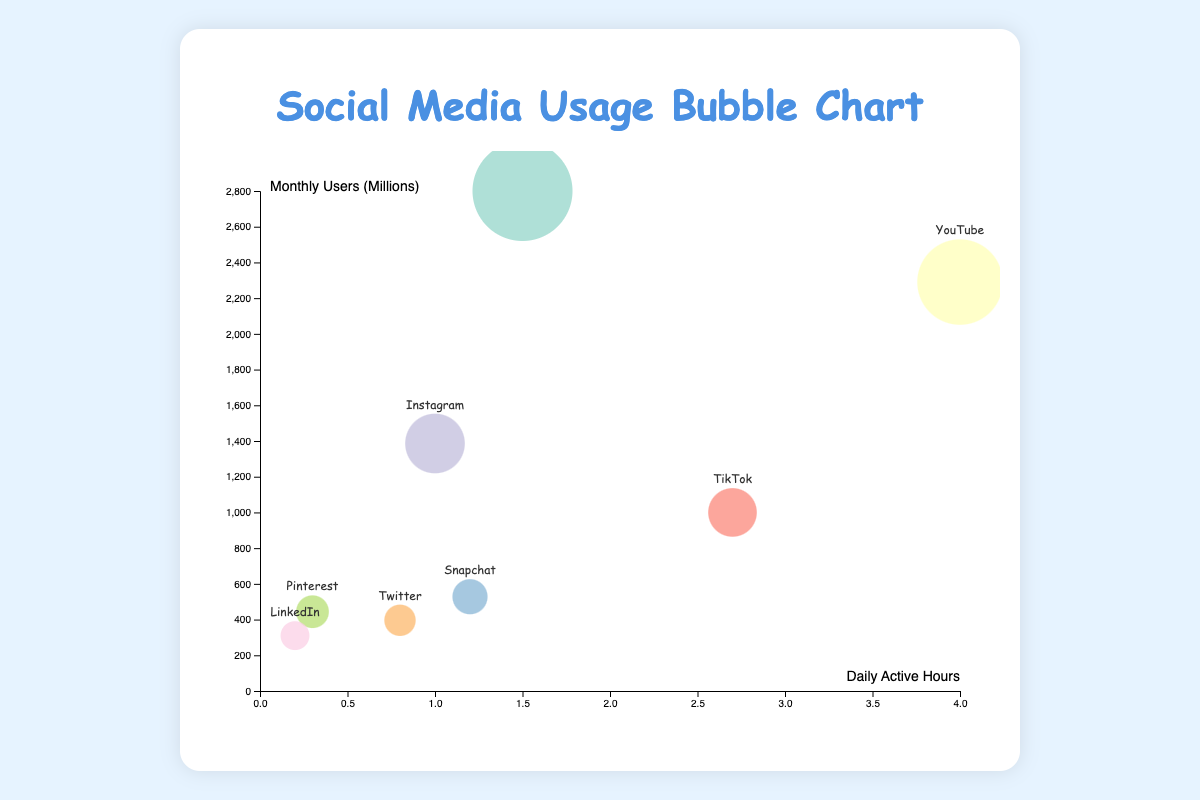What platform has the highest daily active hours? Look at the x-axis (Daily Active Hours) and identify the platform with the furthest point to the right.
Answer: YouTube What's the range of monthly users for the platforms shown? Find the maximum and minimum values on the y-axis (Monthly Users), and calculate the difference. The maximum is 2800 million (Facebook) and the minimum is 310 million (LinkedIn). So, 2800 - 310 = 2490 million.
Answer: 2490 million Which platform has the smallest bubble size? The bubble size represents the number of monthly users. Find the smallest bubble, which corresponds to LinkedIn.
Answer: LinkedIn Between Instagram and TikTok, which platform has more daily active hours? Compare the positions of Instagram and TikTok along the x-axis (Daily Active Hours). Instagram is at 1 hour, while TikTok is at 2.7 hours.
Answer: TikTok Which two platforms have the closest daily active hours? Examine the x-axis points for each platform and identify the two closest. Pinterest (0.3 hours) and LinkedIn (0.2 hours) are close to each other.
Answer: Pinterest and LinkedIn What's the relationship between daily active hours and monthly users for Snapchat? Locate Snapchat on the chart, note its x and y coordinates (1.2 hours, 528 million), and describe the relationship.
Answer: 1.2 hours, 528 million Calculate the average daily active hours of all platforms. Sum the daily active hours and divide by the number of platforms. (1.5 + 4 + 1 + 2.7 + 1.2 + 0.8 + 0.3 + 0.2) / 8 = 1.4625 hours.
Answer: 1.46 hours Which platform has fewer users but high daily active hours? Identify a platform with relatively small bubbles (fewer users) but positioned further right (high daily active hours). TikTok fits this description.
Answer: TikTok Which social media platform has the largest bubble, and what does it represent? Find the largest bubble on the chart. It represents Facebook and indicates the highest number of monthly users.
Answer: Facebook, monthly users 